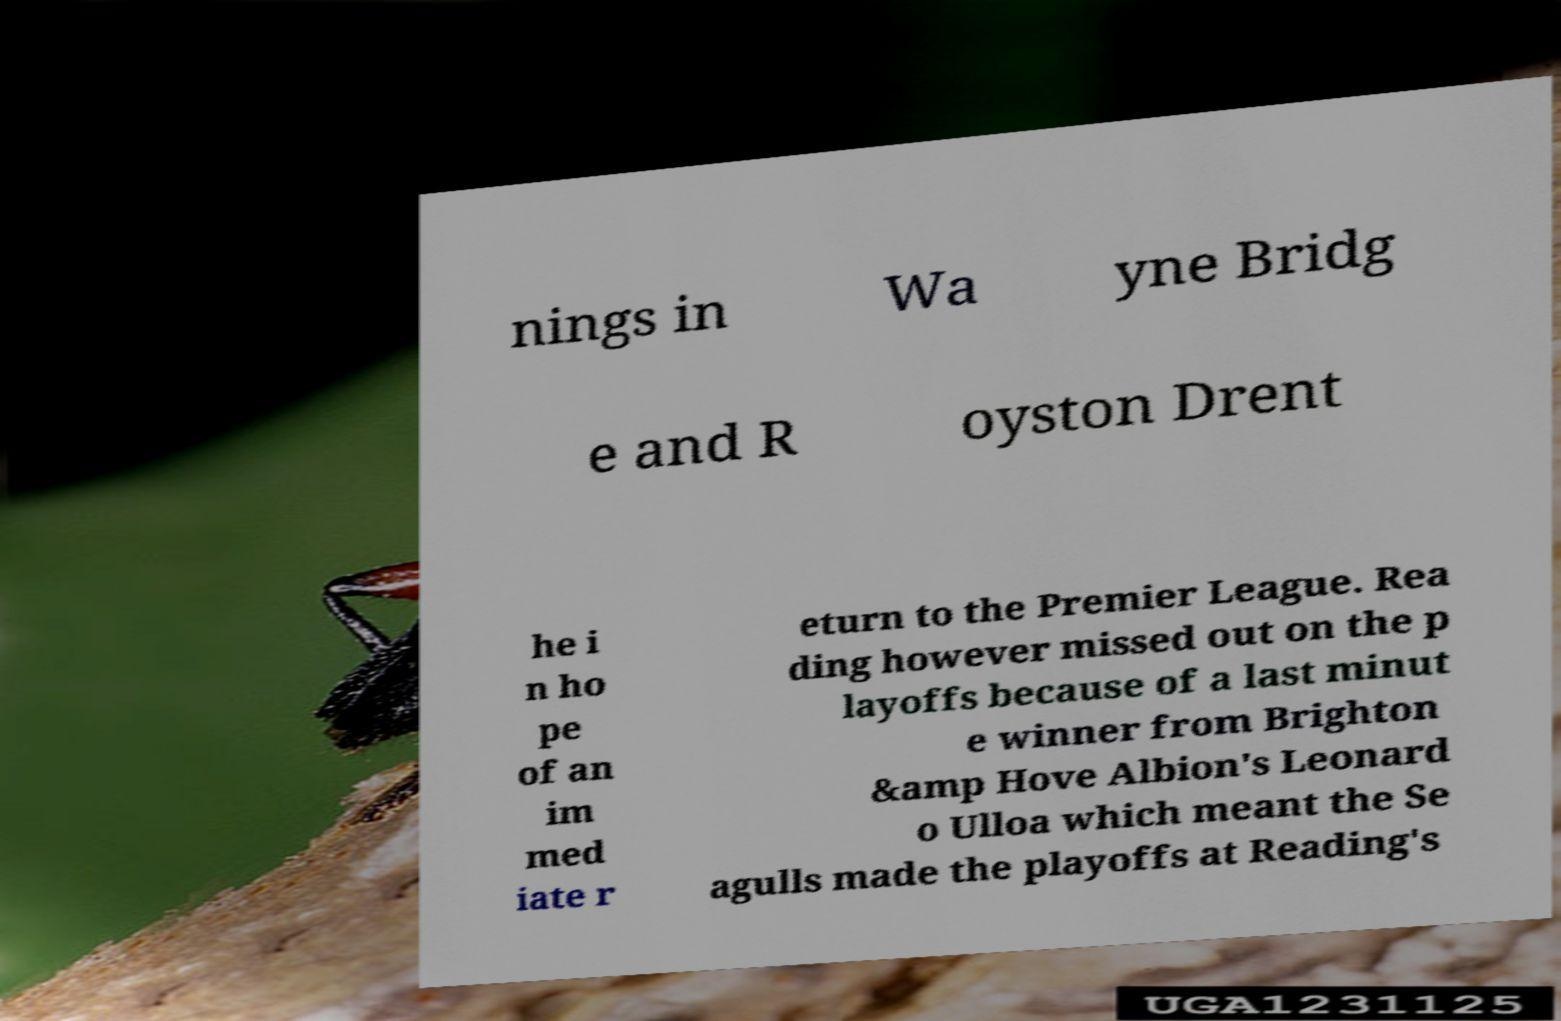For documentation purposes, I need the text within this image transcribed. Could you provide that? nings in Wa yne Bridg e and R oyston Drent he i n ho pe of an im med iate r eturn to the Premier League. Rea ding however missed out on the p layoffs because of a last minut e winner from Brighton &amp Hove Albion's Leonard o Ulloa which meant the Se agulls made the playoffs at Reading's 